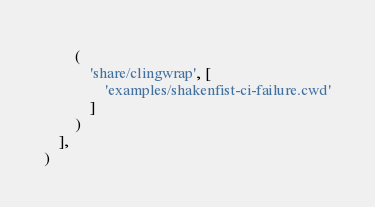<code> <loc_0><loc_0><loc_500><loc_500><_Python_>        (
            'share/clingwrap', [
                'examples/shakenfist-ci-failure.cwd'
            ]
        )
    ],
)
</code> 